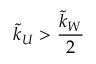Convert formula to latex. <formula><loc_0><loc_0><loc_500><loc_500>\tilde { k } _ { U } > \frac { \tilde { k } _ { W } } { 2 }</formula> 